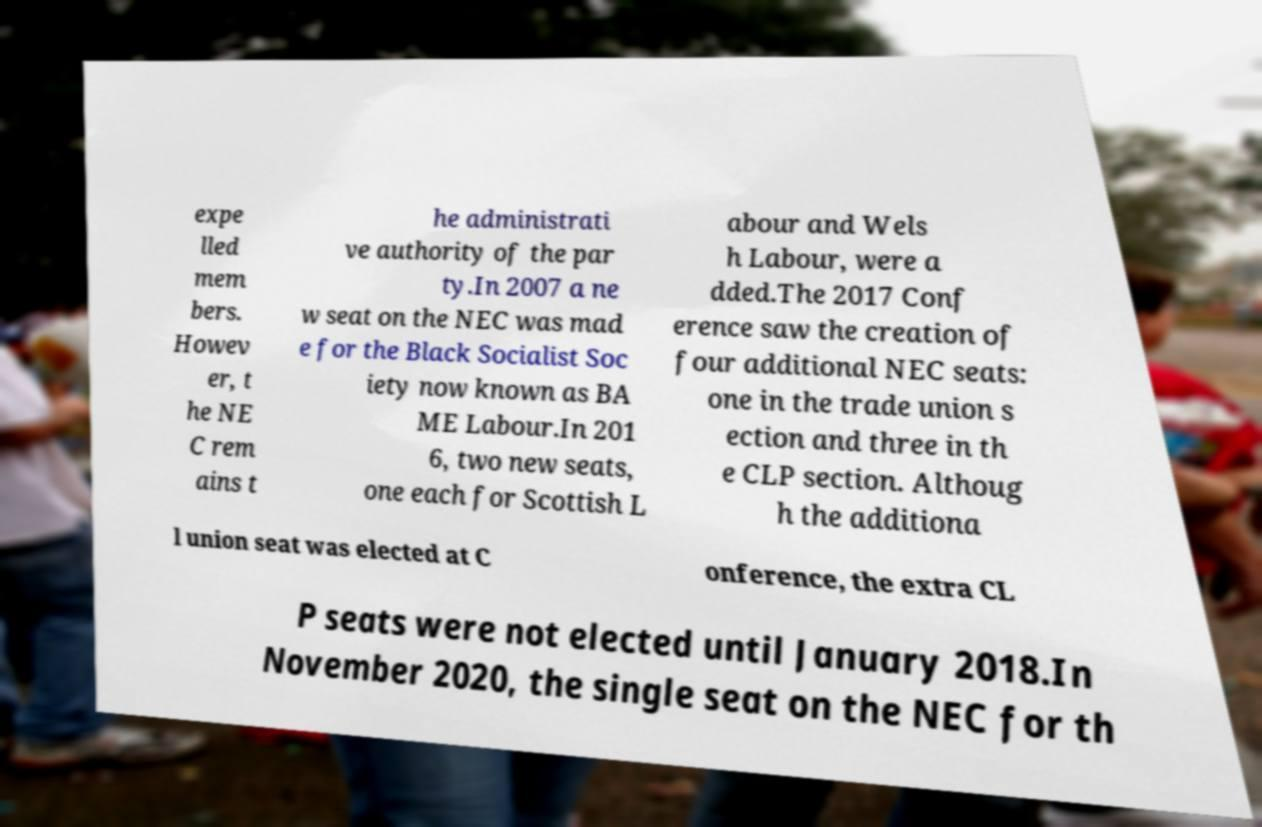Can you read and provide the text displayed in the image?This photo seems to have some interesting text. Can you extract and type it out for me? expe lled mem bers. Howev er, t he NE C rem ains t he administrati ve authority of the par ty.In 2007 a ne w seat on the NEC was mad e for the Black Socialist Soc iety now known as BA ME Labour.In 201 6, two new seats, one each for Scottish L abour and Wels h Labour, were a dded.The 2017 Conf erence saw the creation of four additional NEC seats: one in the trade union s ection and three in th e CLP section. Althoug h the additiona l union seat was elected at C onference, the extra CL P seats were not elected until January 2018.In November 2020, the single seat on the NEC for th 